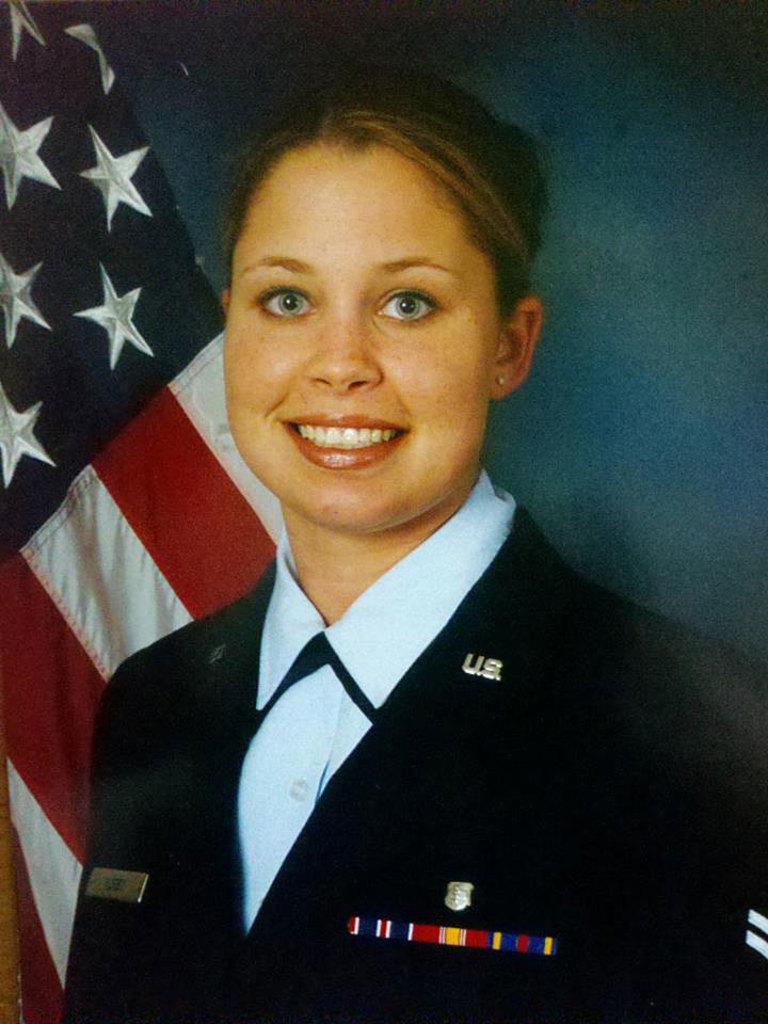Could you give a brief overview of what you see in this image? In the image there is a woman in the foreground, she is smiling and behind her there is an american flag. 